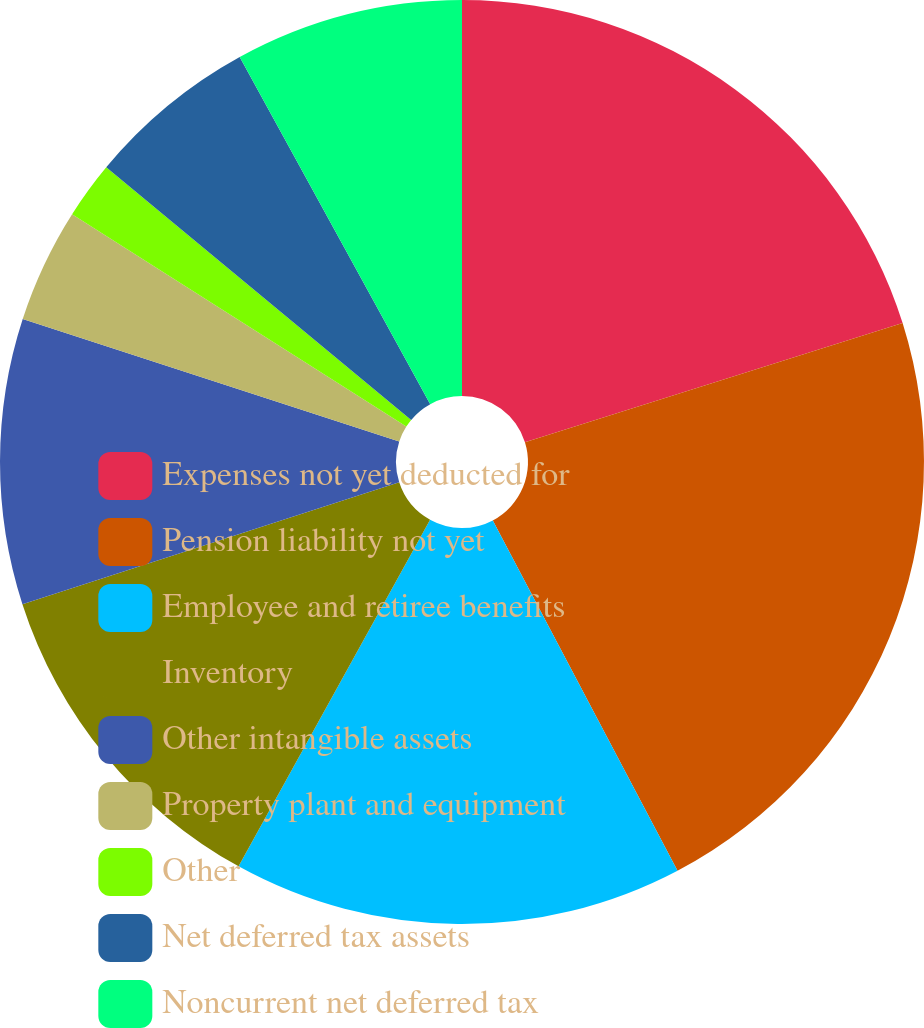Convert chart. <chart><loc_0><loc_0><loc_500><loc_500><pie_chart><fcel>Expenses not yet deducted for<fcel>Pension liability not yet<fcel>Employee and retiree benefits<fcel>Inventory<fcel>Other intangible assets<fcel>Property plant and equipment<fcel>Other<fcel>Net deferred tax assets<fcel>Noncurrent net deferred tax<nl><fcel>20.14%<fcel>22.14%<fcel>15.76%<fcel>11.99%<fcel>9.99%<fcel>4.0%<fcel>2.0%<fcel>6.0%<fcel>7.99%<nl></chart> 